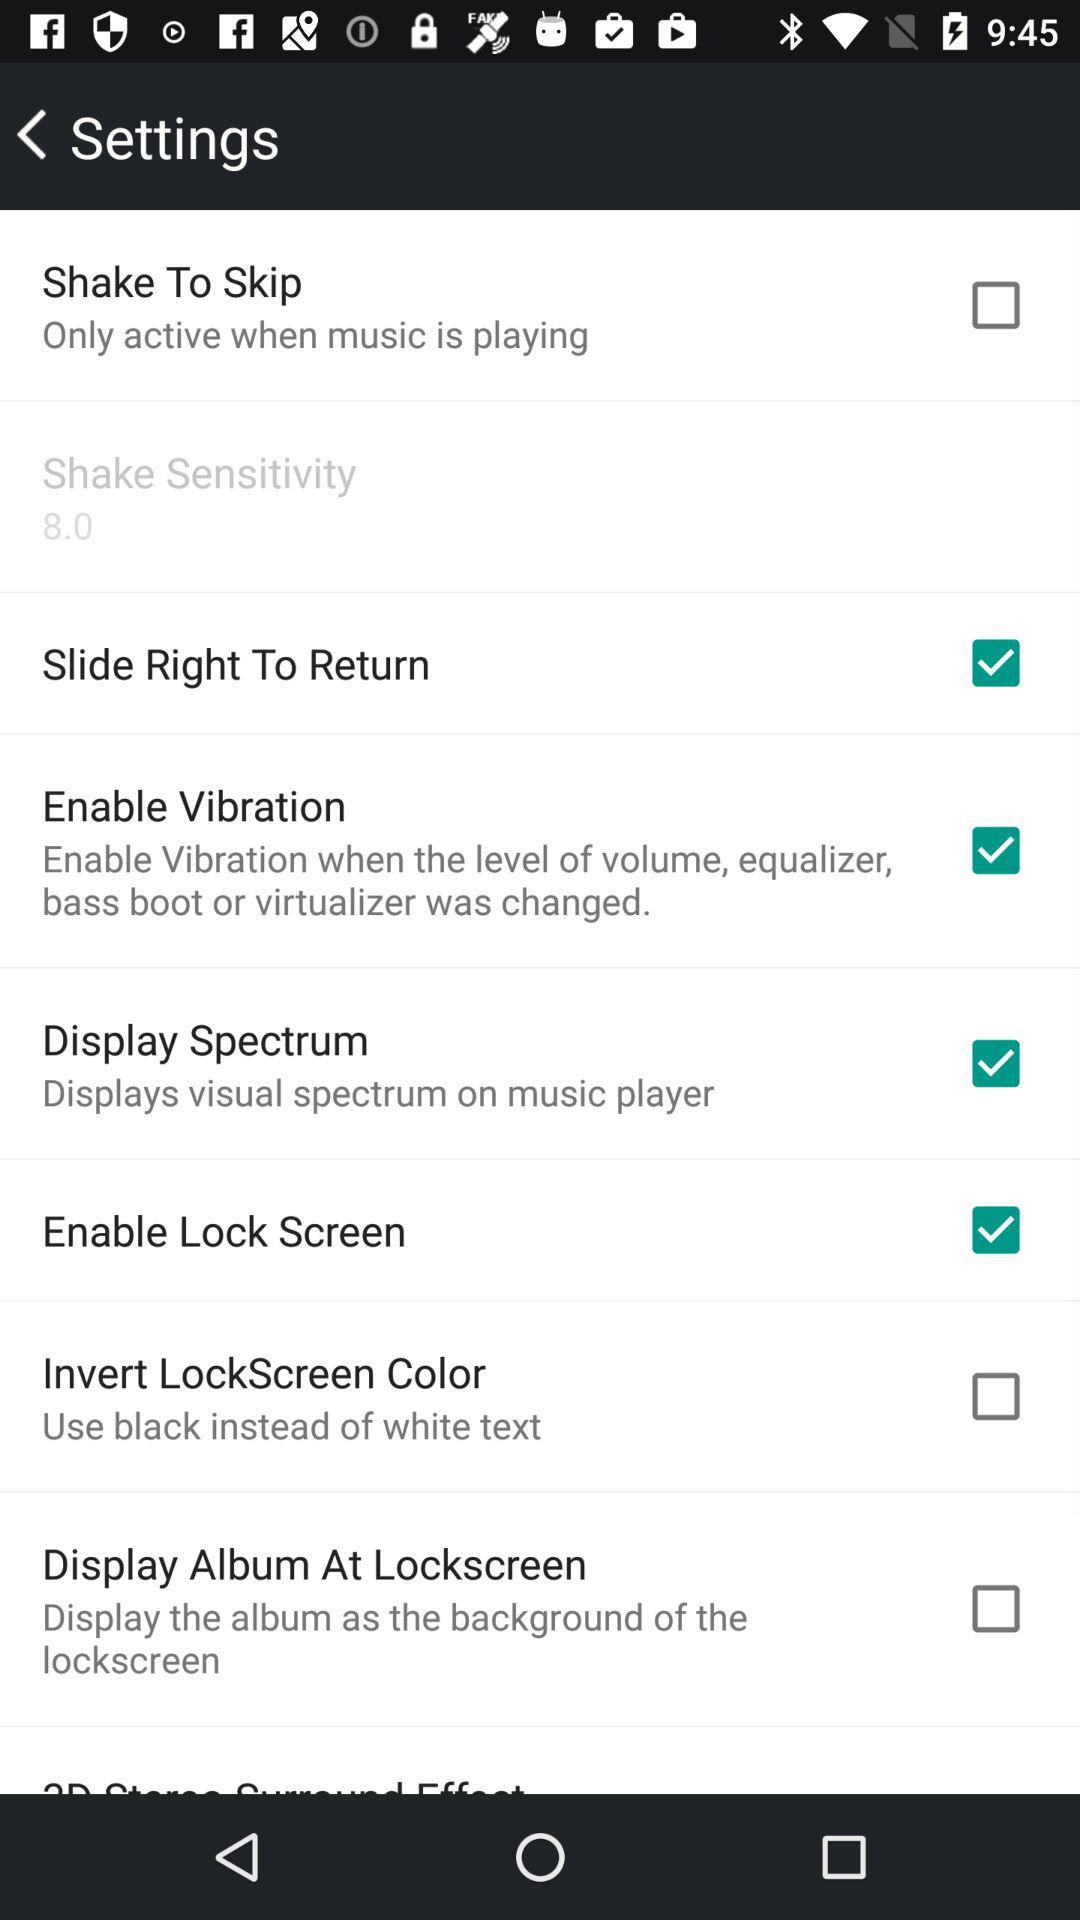What is the setting for shake sensitivity? The setting for shake sensitivity is 8. 